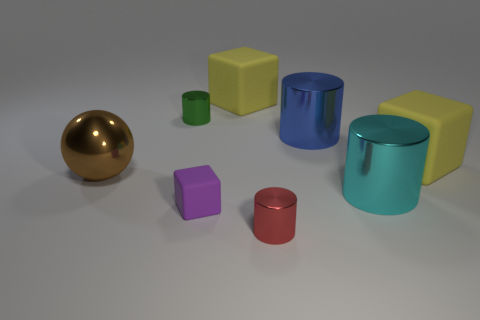What number of shiny things are the same color as the ball?
Provide a short and direct response. 0. Is there anything else that has the same shape as the blue thing?
Make the answer very short. Yes. Is there a thing in front of the big cube that is left of the yellow rubber object to the right of the large cyan shiny object?
Give a very brief answer. Yes. How many large blue things are the same material as the cyan cylinder?
Provide a short and direct response. 1. There is a ball that is left of the tiny purple rubber cube; is it the same size as the matte object that is in front of the brown sphere?
Your answer should be compact. No. The large matte object that is left of the big rubber object that is to the right of the object that is in front of the small matte thing is what color?
Your response must be concise. Yellow. Is there a small metal object of the same shape as the large brown metallic thing?
Give a very brief answer. No. Are there an equal number of green metal objects that are in front of the small red cylinder and large blue shiny cylinders that are on the right side of the cyan shiny cylinder?
Offer a terse response. Yes. There is a large yellow rubber object that is behind the green metal cylinder; is its shape the same as the red object?
Give a very brief answer. No. Does the big blue object have the same shape as the green metal object?
Ensure brevity in your answer.  Yes. 